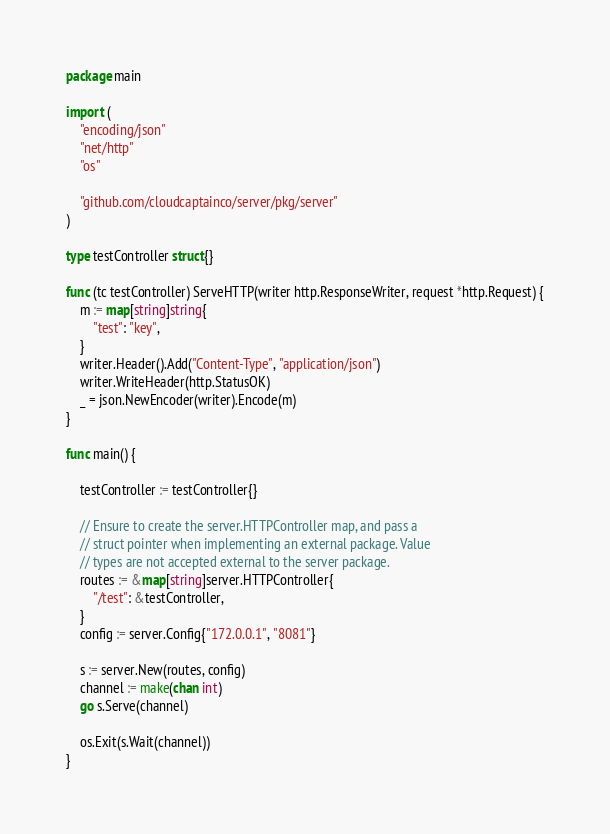Convert code to text. <code><loc_0><loc_0><loc_500><loc_500><_Go_>package main

import (
	"encoding/json"
	"net/http"
	"os"

	"github.com/cloudcaptainco/server/pkg/server"
)

type testController struct{}

func (tc testController) ServeHTTP(writer http.ResponseWriter, request *http.Request) {
	m := map[string]string{
		"test": "key",
	}
	writer.Header().Add("Content-Type", "application/json")
	writer.WriteHeader(http.StatusOK)
	_ = json.NewEncoder(writer).Encode(m)
}

func main() {

	testController := testController{}

	// Ensure to create the server.HTTPController map, and pass a
	// struct pointer when implementing an external package. Value
	// types are not accepted external to the server package.
	routes := &map[string]server.HTTPController{
		"/test": &testController,
	}
	config := server.Config{"172.0.0.1", "8081"}

	s := server.New(routes, config)
	channel := make(chan int)
	go s.Serve(channel)

	os.Exit(s.Wait(channel))
}
</code> 